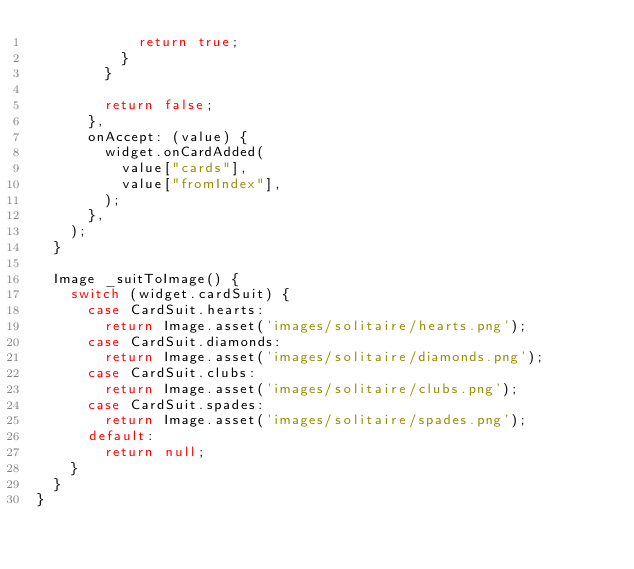Convert code to text. <code><loc_0><loc_0><loc_500><loc_500><_Dart_>            return true;
          }
        }

        return false;
      },
      onAccept: (value) {
        widget.onCardAdded(
          value["cards"],
          value["fromIndex"],
        );
      },
    );
  }

  Image _suitToImage() {
    switch (widget.cardSuit) {
      case CardSuit.hearts:
        return Image.asset('images/solitaire/hearts.png');
      case CardSuit.diamonds:
        return Image.asset('images/solitaire/diamonds.png');
      case CardSuit.clubs:
        return Image.asset('images/solitaire/clubs.png');
      case CardSuit.spades:
        return Image.asset('images/solitaire/spades.png');
      default:
        return null;
    }
  }
}
</code> 